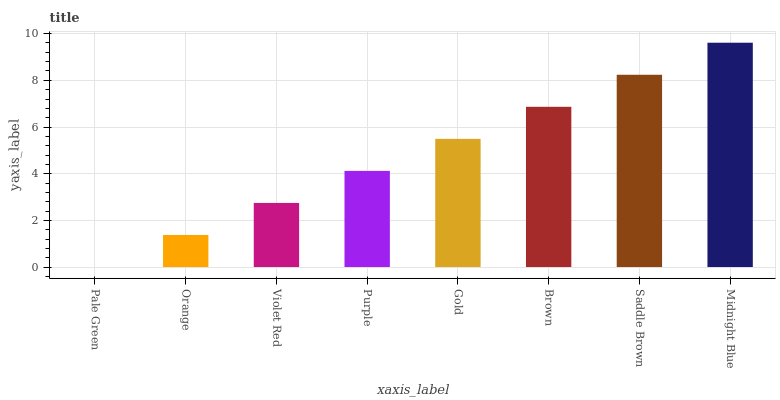Is Pale Green the minimum?
Answer yes or no. Yes. Is Midnight Blue the maximum?
Answer yes or no. Yes. Is Orange the minimum?
Answer yes or no. No. Is Orange the maximum?
Answer yes or no. No. Is Orange greater than Pale Green?
Answer yes or no. Yes. Is Pale Green less than Orange?
Answer yes or no. Yes. Is Pale Green greater than Orange?
Answer yes or no. No. Is Orange less than Pale Green?
Answer yes or no. No. Is Gold the high median?
Answer yes or no. Yes. Is Purple the low median?
Answer yes or no. Yes. Is Saddle Brown the high median?
Answer yes or no. No. Is Midnight Blue the low median?
Answer yes or no. No. 